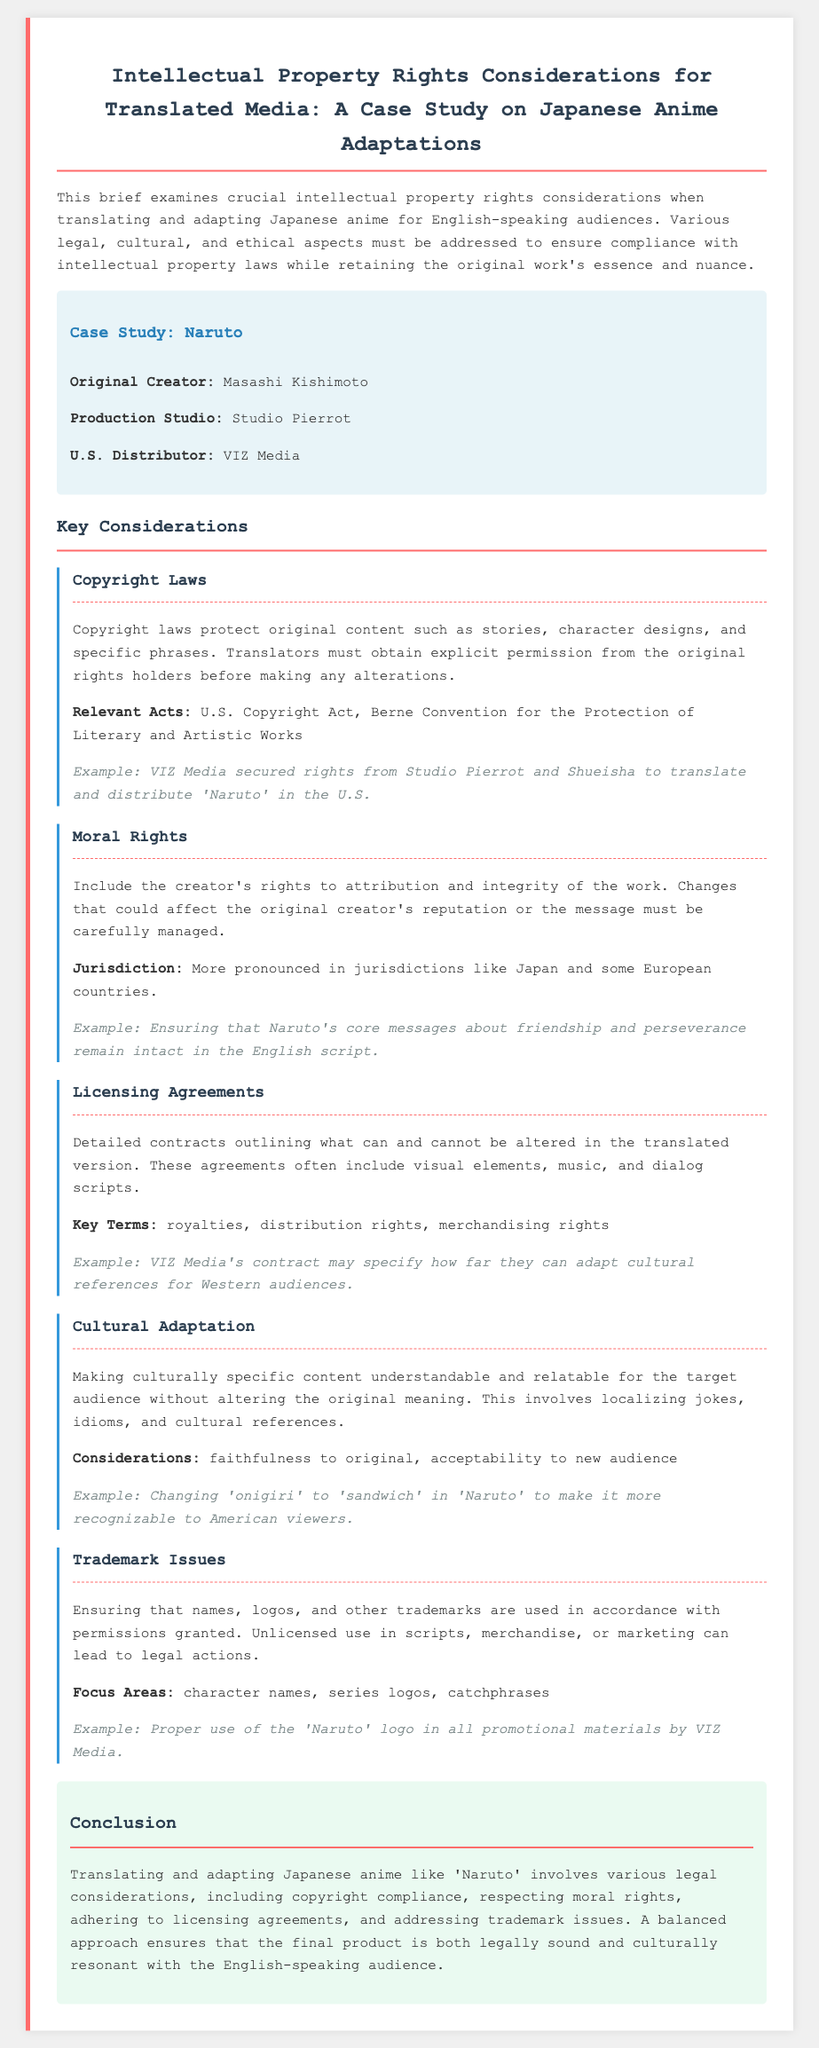What is the original creator of Naruto? The document states that the original creator of Naruto is Masashi Kishimoto.
Answer: Masashi Kishimoto Which U.S. distributor handles Naruto? According to the document, Naruto is distributed by VIZ Media in the U.S.
Answer: VIZ Media What are moral rights? The document explains moral rights as the creator's rights to attribution and integrity of the work.
Answer: Creator's rights What is one of the relevant acts mentioned for copyright laws? The document lists the U.S. Copyright Act as one of the relevant acts for copyright laws.
Answer: U.S. Copyright Act What example of cultural adaptation is provided? The document mentions changing 'onigiri' to 'sandwich' in Naruto as an example of cultural adaptation.
Answer: 'onigiri' to 'sandwich' How many key considerations are discussed in the document? The document outlines five key considerations related to intellectual property rights for translated media.
Answer: Five What must translators obtain from the original rights holders before making alterations? Translators must obtain explicit permission from the original rights holders according to the document.
Answer: Explicit permission Which production studio created Naruto? The document states that Studio Pierrot is the production studio for Naruto.
Answer: Studio Pierrot What major aspect must be ensured to prevent legal actions according to the trademark issues? The document highlights that ensuring names, logos, and trademarks are used with permissions granted is crucial.
Answer: Permissions granted 